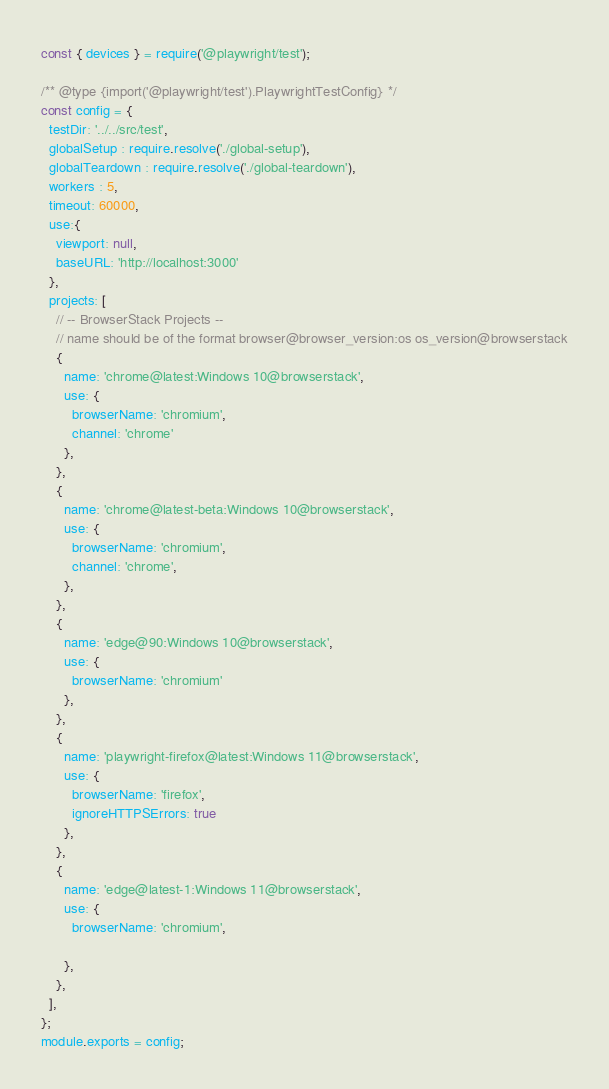Convert code to text. <code><loc_0><loc_0><loc_500><loc_500><_JavaScript_>const { devices } = require('@playwright/test');

/** @type {import('@playwright/test').PlaywrightTestConfig} */
const config = {
  testDir: '../../src/test',
  globalSetup : require.resolve('./global-setup'),
  globalTeardown : require.resolve('./global-teardown'),
  workers : 5,
  timeout: 60000,
  use:{
    viewport: null,
    baseURL: 'http://localhost:3000'
  },
  projects: [
    // -- BrowserStack Projects --
    // name should be of the format browser@browser_version:os os_version@browserstack
    {
      name: 'chrome@latest:Windows 10@browserstack',
      use: {
        browserName: 'chromium',
        channel: 'chrome'
      },
    },
    {
      name: 'chrome@latest-beta:Windows 10@browserstack',
      use: {
        browserName: 'chromium',
        channel: 'chrome',
      },
    },
    {
      name: 'edge@90:Windows 10@browserstack',
      use: {
        browserName: 'chromium'
      },
    },
    {
      name: 'playwright-firefox@latest:Windows 11@browserstack',
      use: {
        browserName: 'firefox',
        ignoreHTTPSErrors: true
      },
    },
    {
      name: 'edge@latest-1:Windows 11@browserstack',
      use: {
        browserName: 'chromium',
       
      },
    },
  ],
};
module.exports = config;
</code> 